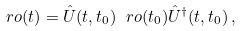<formula> <loc_0><loc_0><loc_500><loc_500>\ r o ( t ) = \hat { U } ( t , t _ { 0 } ) \ r o ( t _ { 0 } ) \hat { U } ^ { \dag } ( t , t _ { 0 } ) \, ,</formula> 